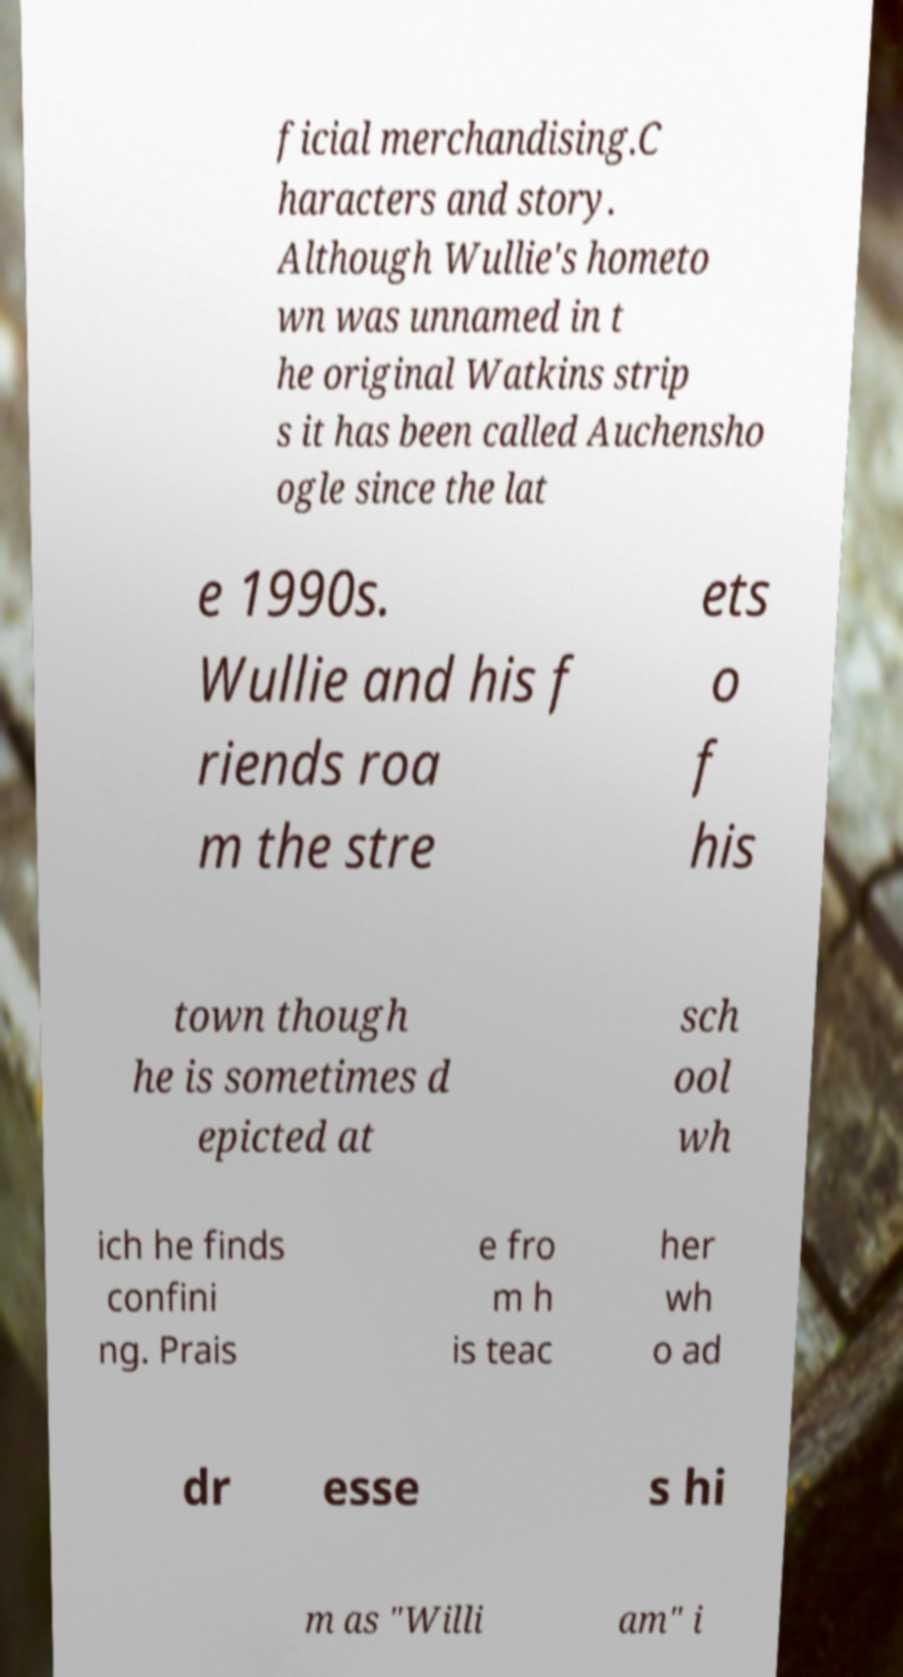I need the written content from this picture converted into text. Can you do that? ficial merchandising.C haracters and story. Although Wullie's hometo wn was unnamed in t he original Watkins strip s it has been called Auchensho ogle since the lat e 1990s. Wullie and his f riends roa m the stre ets o f his town though he is sometimes d epicted at sch ool wh ich he finds confini ng. Prais e fro m h is teac her wh o ad dr esse s hi m as "Willi am" i 